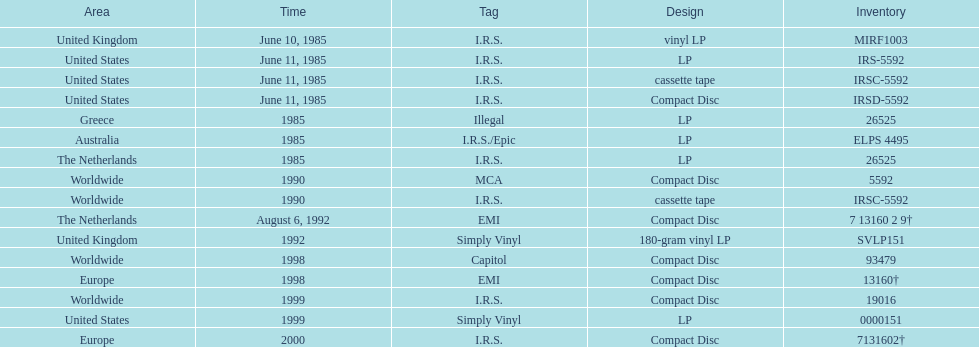How many times was the album released? 13. 